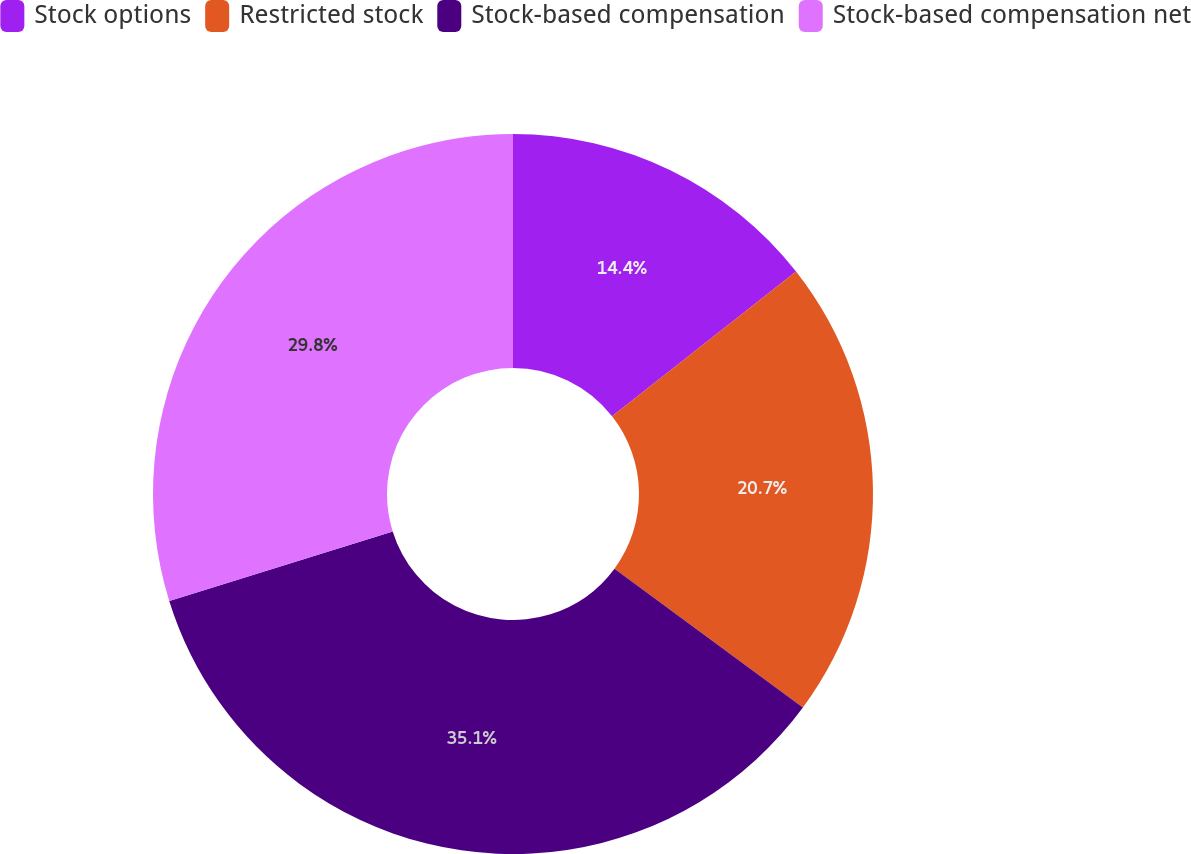Convert chart. <chart><loc_0><loc_0><loc_500><loc_500><pie_chart><fcel>Stock options<fcel>Restricted stock<fcel>Stock-based compensation<fcel>Stock-based compensation net<nl><fcel>14.4%<fcel>20.7%<fcel>35.1%<fcel>29.8%<nl></chart> 